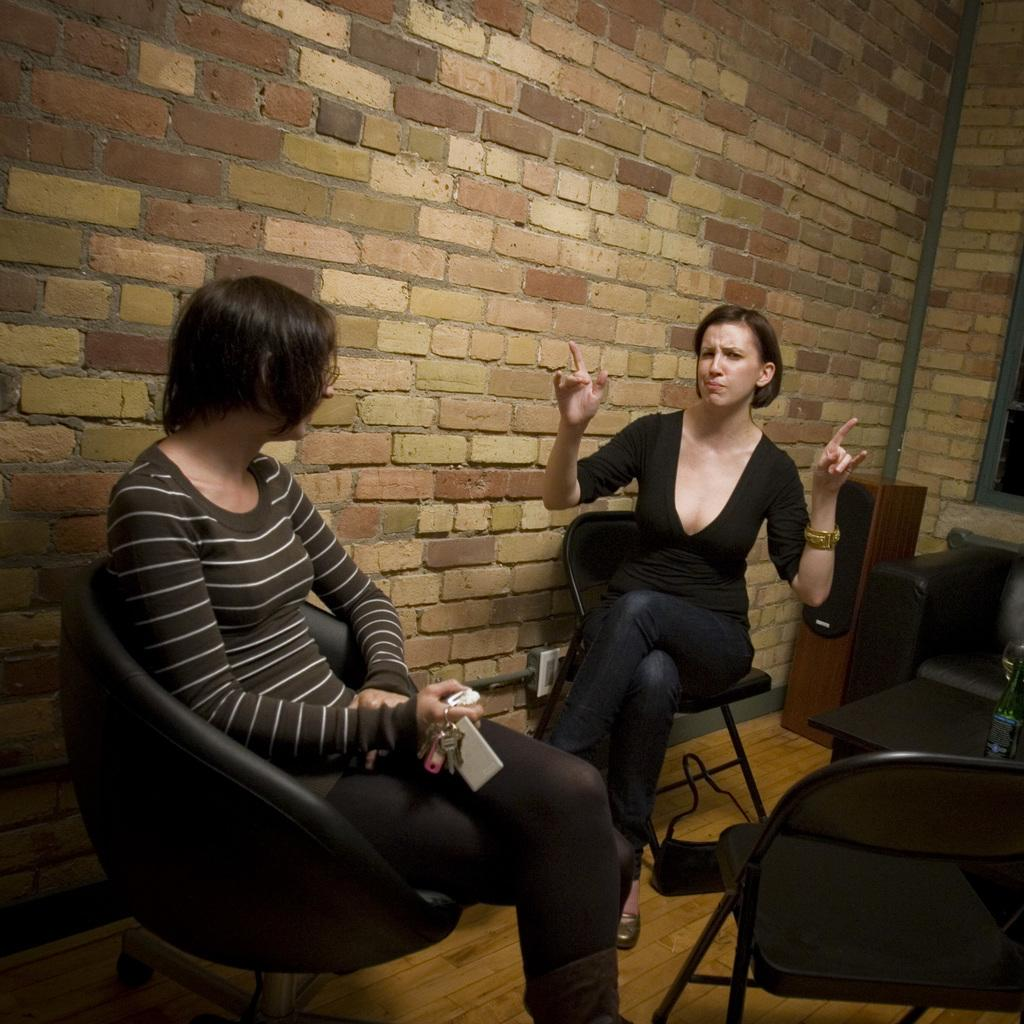How many people are sitting in the image? There are two people sitting on chairs in the image. What is on the table in the image? There is a bottle on the table in the image. What is the woman holding in the image? The woman is holding keys in the image. What is on the wooden floor in the image? There is a bag on the wooden floor in the image. What can be used for amplifying sound in the image? There is a speaker in the image. How much celery is visible in the image? There is no celery present in the image. How many times does the woman fold the keys in the image? The woman is not folding the keys in the image; she is simply holding them. 